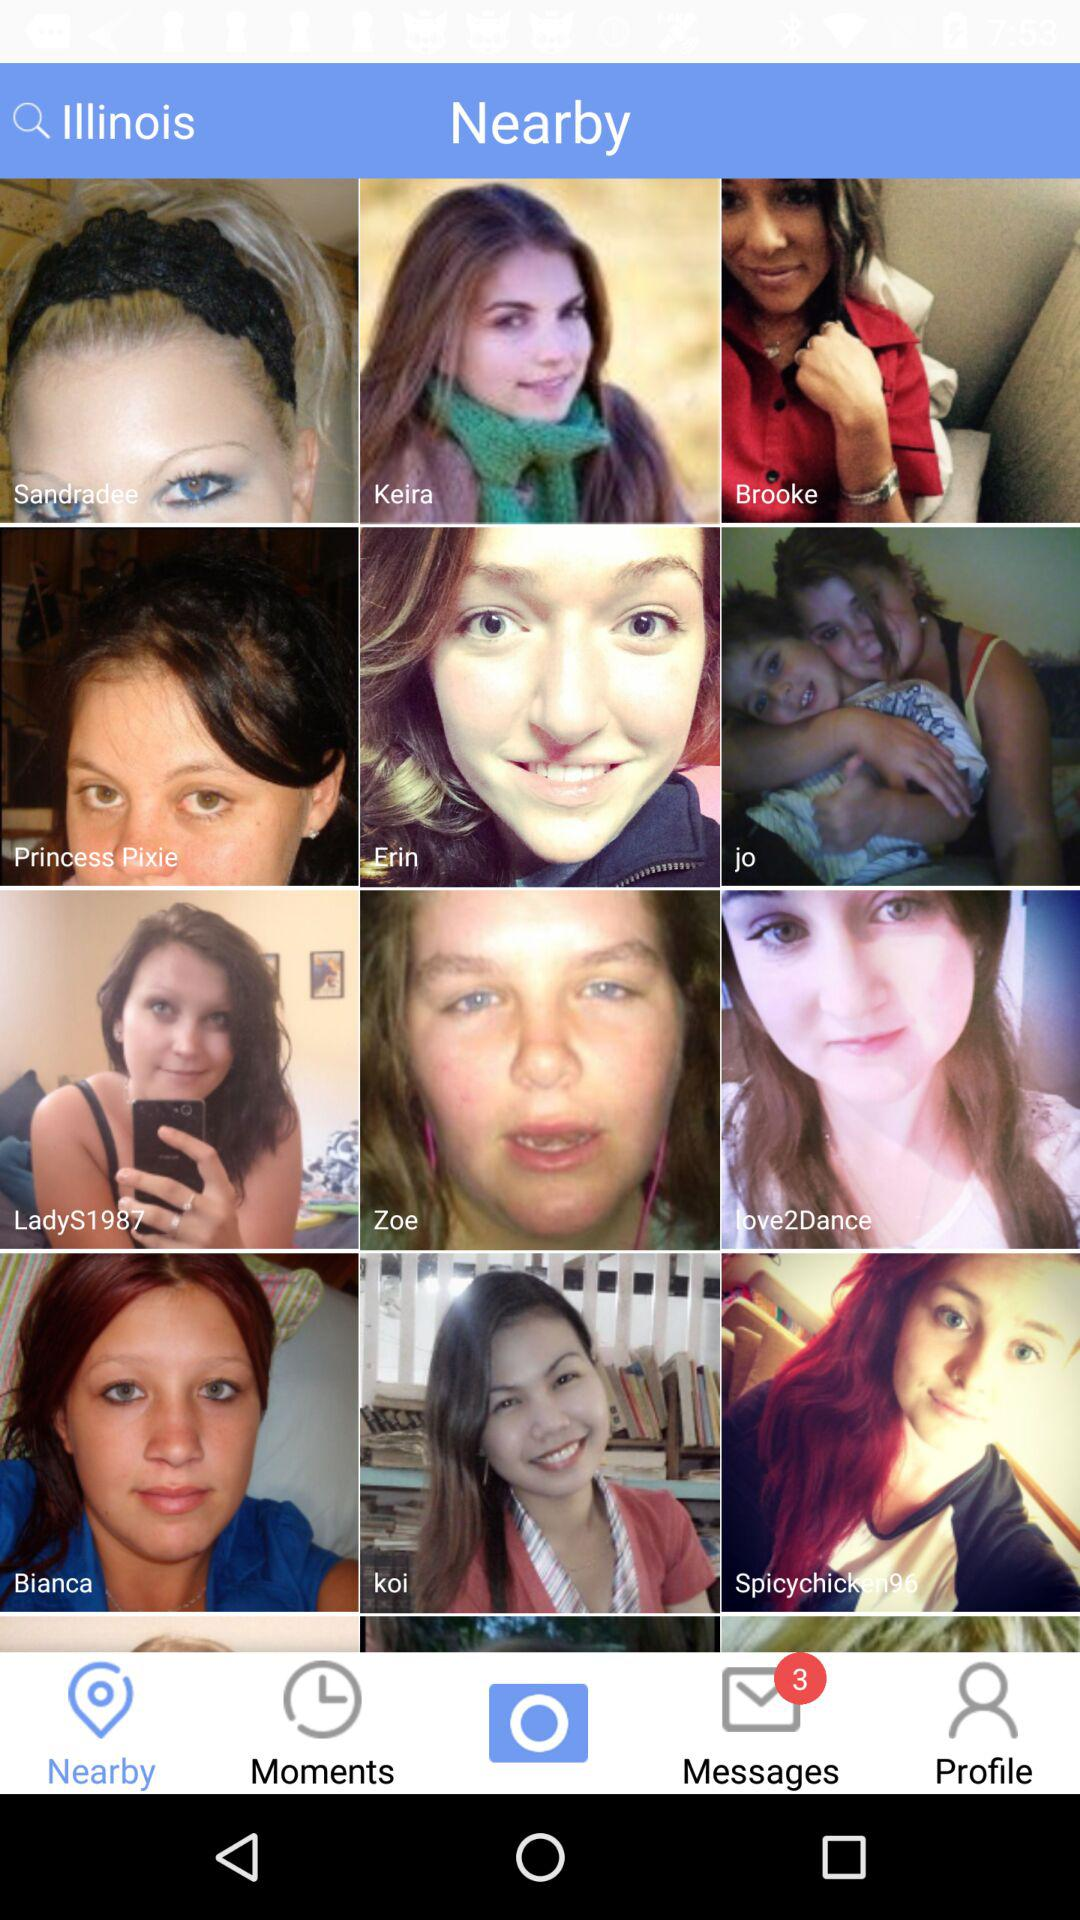Which tab is selected? The selected tab is "Nearby". 